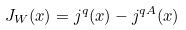Convert formula to latex. <formula><loc_0><loc_0><loc_500><loc_500>J _ { W } ( x ) = j ^ { q } ( x ) - j ^ { q A } ( x )</formula> 